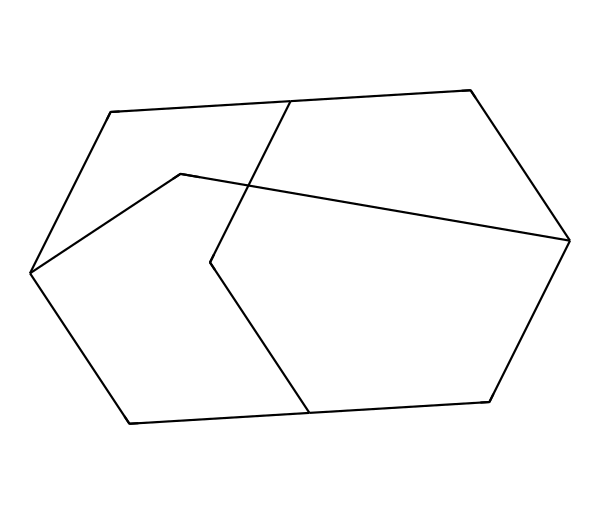What is the name of this chemical compound? The provided SMILES represents adamantane, which is a well-known cage compound characterized by its unique three-dimensional structure resembling a diamond.
Answer: adamantane How many carbon atoms are in the molecular structure? By analyzing the SMILES notation, we can count 10 carbon atoms (C). Each "C" in the SMILES corresponds to a carbon atom in the structure.
Answer: 10 What type of bonding is primarily present in this compound? Observing the structure, it primarily consists of carbon-carbon single bonds, characteristic of saturated hydrocarbons, which are fully bonded without double or triple bonds.
Answer: single bonds Does this compound have any rings in its structure? The molecular structure exhibits a cage-like arrangement with multiple interconnected rings, confirming the presence of cycloalkane components within adamantane.
Answer: yes What is the overall molecular symmetry of adamantane? Examining the three-dimensional layout of adamantane, it shows high symmetry, primarily reflective of its tetrahedral arrangement of carbon atoms, leading to its uniform properties.
Answer: high symmetry How many hydrogen atoms are attached to the carbon atoms? Each carbon atom in adamantane is bonded to enough hydrogen atoms to satisfy carbon's tetravalency, resulting in a total of 18 hydrogen atoms in the structure.
Answer: 18 What category of compounds does adamantane belong to? Adamantane is classified under the category of polycyclic hydrocarbons, specifically recognized as a cage compound due to its rigid, multi-cyclic structure.
Answer: cage compound 